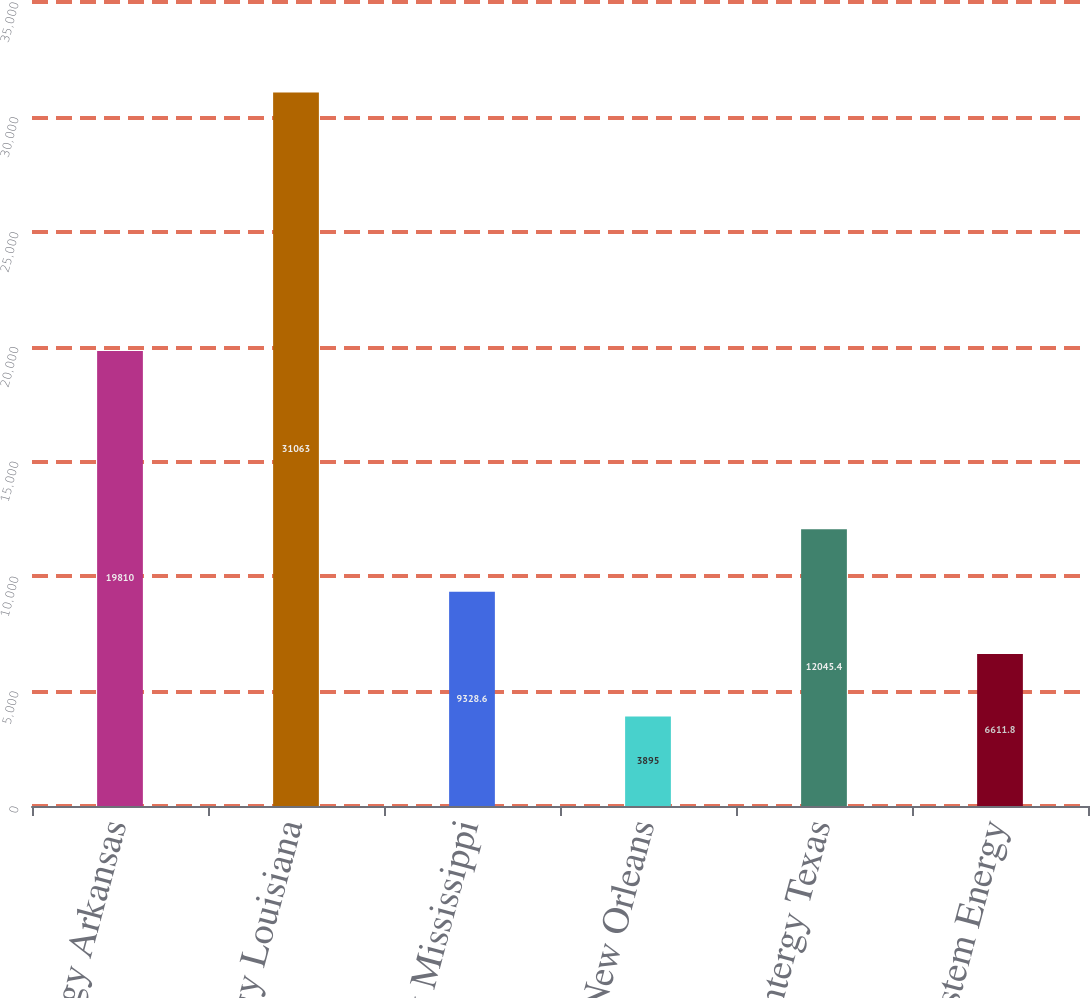<chart> <loc_0><loc_0><loc_500><loc_500><bar_chart><fcel>Entergy Arkansas<fcel>Entergy Louisiana<fcel>Entergy Mississippi<fcel>Entergy New Orleans<fcel>Entergy Texas<fcel>System Energy<nl><fcel>19810<fcel>31063<fcel>9328.6<fcel>3895<fcel>12045.4<fcel>6611.8<nl></chart> 